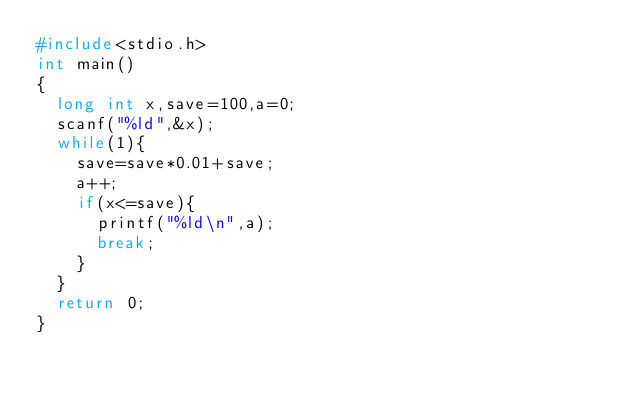<code> <loc_0><loc_0><loc_500><loc_500><_C_>#include<stdio.h>
int main()
{
  long int x,save=100,a=0;
  scanf("%ld",&x);
  while(1){
    save=save*0.01+save;
    a++;
    if(x<=save){
      printf("%ld\n",a);
      break;
    }
  }
  return 0;
}
</code> 